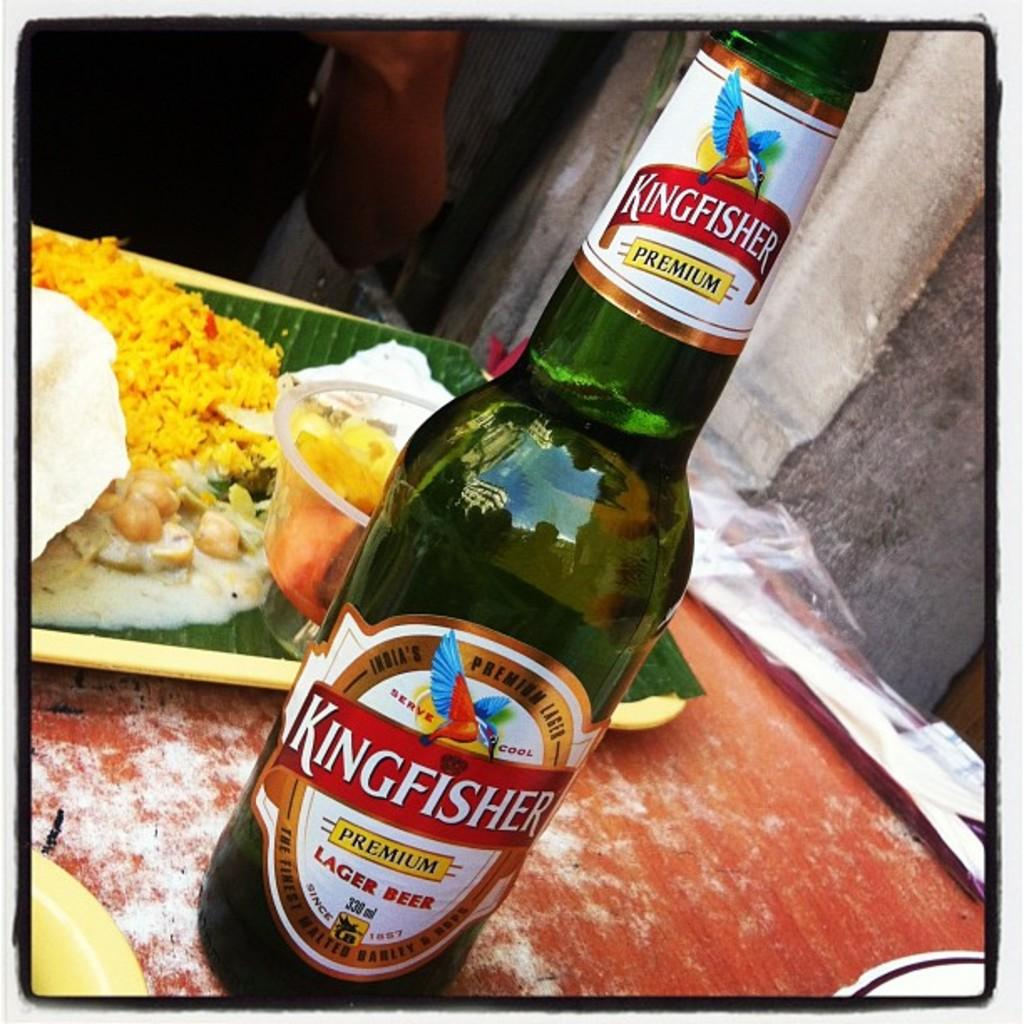What object can be seen in the image with a label attached to it? There is a bottle in the image with a label attached to it. What is the food item on the plate in the image? Unfortunately, the provided facts do not mention the specific food item on the plate. Can you describe the label on the bottle? The facts do not provide any information about the label's content or appearance. How does the son interact with the bottle in the image? There is no mention of a son or any person interacting with the bottle in the provided facts. 